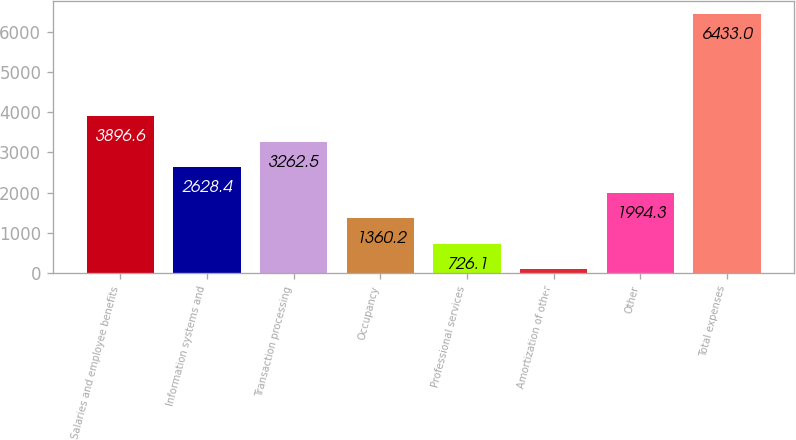Convert chart to OTSL. <chart><loc_0><loc_0><loc_500><loc_500><bar_chart><fcel>Salaries and employee benefits<fcel>Information systems and<fcel>Transaction processing<fcel>Occupancy<fcel>Professional services<fcel>Amortization of other<fcel>Other<fcel>Total expenses<nl><fcel>3896.6<fcel>2628.4<fcel>3262.5<fcel>1360.2<fcel>726.1<fcel>92<fcel>1994.3<fcel>6433<nl></chart> 